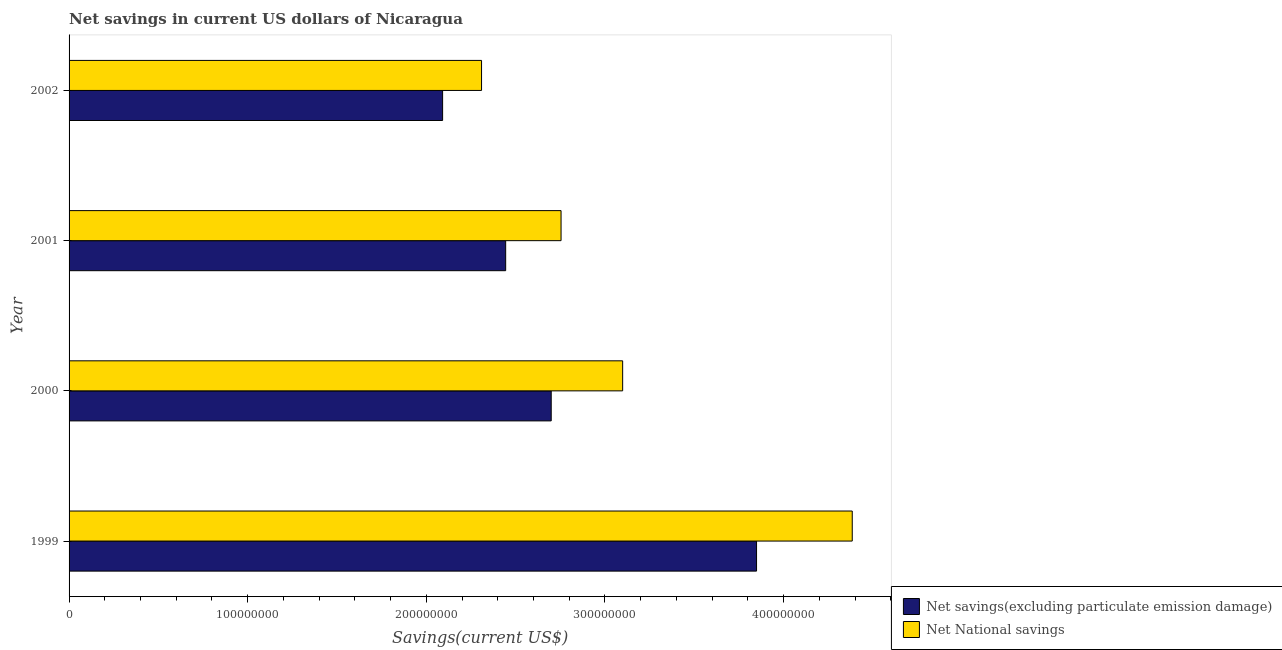How many groups of bars are there?
Offer a terse response. 4. Are the number of bars on each tick of the Y-axis equal?
Provide a short and direct response. Yes. How many bars are there on the 1st tick from the top?
Give a very brief answer. 2. In how many cases, is the number of bars for a given year not equal to the number of legend labels?
Ensure brevity in your answer.  0. What is the net savings(excluding particulate emission damage) in 2002?
Ensure brevity in your answer.  2.09e+08. Across all years, what is the maximum net savings(excluding particulate emission damage)?
Offer a terse response. 3.85e+08. Across all years, what is the minimum net national savings?
Your answer should be compact. 2.31e+08. In which year was the net savings(excluding particulate emission damage) minimum?
Ensure brevity in your answer.  2002. What is the total net national savings in the graph?
Keep it short and to the point. 1.25e+09. What is the difference between the net savings(excluding particulate emission damage) in 2000 and that in 2002?
Provide a succinct answer. 6.08e+07. What is the difference between the net savings(excluding particulate emission damage) in 2000 and the net national savings in 2001?
Ensure brevity in your answer.  -5.50e+06. What is the average net savings(excluding particulate emission damage) per year?
Make the answer very short. 2.77e+08. In the year 2002, what is the difference between the net national savings and net savings(excluding particulate emission damage)?
Provide a short and direct response. 2.18e+07. What is the ratio of the net national savings in 2000 to that in 2002?
Offer a very short reply. 1.34. Is the difference between the net savings(excluding particulate emission damage) in 2000 and 2002 greater than the difference between the net national savings in 2000 and 2002?
Offer a terse response. No. What is the difference between the highest and the second highest net savings(excluding particulate emission damage)?
Give a very brief answer. 1.15e+08. What is the difference between the highest and the lowest net savings(excluding particulate emission damage)?
Offer a very short reply. 1.76e+08. What does the 2nd bar from the top in 2002 represents?
Ensure brevity in your answer.  Net savings(excluding particulate emission damage). What does the 1st bar from the bottom in 2000 represents?
Your response must be concise. Net savings(excluding particulate emission damage). How many bars are there?
Your response must be concise. 8. How many years are there in the graph?
Ensure brevity in your answer.  4. What is the difference between two consecutive major ticks on the X-axis?
Give a very brief answer. 1.00e+08. Does the graph contain grids?
Make the answer very short. No. How many legend labels are there?
Your answer should be compact. 2. How are the legend labels stacked?
Provide a short and direct response. Vertical. What is the title of the graph?
Give a very brief answer. Net savings in current US dollars of Nicaragua. What is the label or title of the X-axis?
Give a very brief answer. Savings(current US$). What is the label or title of the Y-axis?
Your answer should be very brief. Year. What is the Savings(current US$) of Net savings(excluding particulate emission damage) in 1999?
Provide a short and direct response. 3.85e+08. What is the Savings(current US$) in Net National savings in 1999?
Offer a very short reply. 4.38e+08. What is the Savings(current US$) of Net savings(excluding particulate emission damage) in 2000?
Provide a succinct answer. 2.70e+08. What is the Savings(current US$) in Net National savings in 2000?
Keep it short and to the point. 3.10e+08. What is the Savings(current US$) of Net savings(excluding particulate emission damage) in 2001?
Ensure brevity in your answer.  2.44e+08. What is the Savings(current US$) of Net National savings in 2001?
Provide a succinct answer. 2.75e+08. What is the Savings(current US$) of Net savings(excluding particulate emission damage) in 2002?
Provide a short and direct response. 2.09e+08. What is the Savings(current US$) of Net National savings in 2002?
Keep it short and to the point. 2.31e+08. Across all years, what is the maximum Savings(current US$) in Net savings(excluding particulate emission damage)?
Provide a short and direct response. 3.85e+08. Across all years, what is the maximum Savings(current US$) of Net National savings?
Offer a terse response. 4.38e+08. Across all years, what is the minimum Savings(current US$) of Net savings(excluding particulate emission damage)?
Ensure brevity in your answer.  2.09e+08. Across all years, what is the minimum Savings(current US$) in Net National savings?
Offer a very short reply. 2.31e+08. What is the total Savings(current US$) of Net savings(excluding particulate emission damage) in the graph?
Offer a terse response. 1.11e+09. What is the total Savings(current US$) of Net National savings in the graph?
Provide a succinct answer. 1.25e+09. What is the difference between the Savings(current US$) in Net savings(excluding particulate emission damage) in 1999 and that in 2000?
Ensure brevity in your answer.  1.15e+08. What is the difference between the Savings(current US$) in Net National savings in 1999 and that in 2000?
Offer a very short reply. 1.29e+08. What is the difference between the Savings(current US$) of Net savings(excluding particulate emission damage) in 1999 and that in 2001?
Ensure brevity in your answer.  1.40e+08. What is the difference between the Savings(current US$) in Net National savings in 1999 and that in 2001?
Give a very brief answer. 1.63e+08. What is the difference between the Savings(current US$) of Net savings(excluding particulate emission damage) in 1999 and that in 2002?
Make the answer very short. 1.76e+08. What is the difference between the Savings(current US$) in Net National savings in 1999 and that in 2002?
Ensure brevity in your answer.  2.08e+08. What is the difference between the Savings(current US$) in Net savings(excluding particulate emission damage) in 2000 and that in 2001?
Make the answer very short. 2.55e+07. What is the difference between the Savings(current US$) of Net National savings in 2000 and that in 2001?
Offer a terse response. 3.45e+07. What is the difference between the Savings(current US$) of Net savings(excluding particulate emission damage) in 2000 and that in 2002?
Make the answer very short. 6.08e+07. What is the difference between the Savings(current US$) of Net National savings in 2000 and that in 2002?
Offer a terse response. 7.90e+07. What is the difference between the Savings(current US$) of Net savings(excluding particulate emission damage) in 2001 and that in 2002?
Make the answer very short. 3.53e+07. What is the difference between the Savings(current US$) of Net National savings in 2001 and that in 2002?
Your response must be concise. 4.45e+07. What is the difference between the Savings(current US$) in Net savings(excluding particulate emission damage) in 1999 and the Savings(current US$) in Net National savings in 2000?
Keep it short and to the point. 7.50e+07. What is the difference between the Savings(current US$) in Net savings(excluding particulate emission damage) in 1999 and the Savings(current US$) in Net National savings in 2001?
Provide a succinct answer. 1.09e+08. What is the difference between the Savings(current US$) of Net savings(excluding particulate emission damage) in 1999 and the Savings(current US$) of Net National savings in 2002?
Your answer should be compact. 1.54e+08. What is the difference between the Savings(current US$) of Net savings(excluding particulate emission damage) in 2000 and the Savings(current US$) of Net National savings in 2001?
Give a very brief answer. -5.50e+06. What is the difference between the Savings(current US$) in Net savings(excluding particulate emission damage) in 2000 and the Savings(current US$) in Net National savings in 2002?
Your response must be concise. 3.90e+07. What is the difference between the Savings(current US$) in Net savings(excluding particulate emission damage) in 2001 and the Savings(current US$) in Net National savings in 2002?
Ensure brevity in your answer.  1.35e+07. What is the average Savings(current US$) in Net savings(excluding particulate emission damage) per year?
Give a very brief answer. 2.77e+08. What is the average Savings(current US$) in Net National savings per year?
Make the answer very short. 3.14e+08. In the year 1999, what is the difference between the Savings(current US$) of Net savings(excluding particulate emission damage) and Savings(current US$) of Net National savings?
Ensure brevity in your answer.  -5.36e+07. In the year 2000, what is the difference between the Savings(current US$) in Net savings(excluding particulate emission damage) and Savings(current US$) in Net National savings?
Your answer should be very brief. -4.00e+07. In the year 2001, what is the difference between the Savings(current US$) of Net savings(excluding particulate emission damage) and Savings(current US$) of Net National savings?
Keep it short and to the point. -3.10e+07. In the year 2002, what is the difference between the Savings(current US$) in Net savings(excluding particulate emission damage) and Savings(current US$) in Net National savings?
Your answer should be compact. -2.18e+07. What is the ratio of the Savings(current US$) in Net savings(excluding particulate emission damage) in 1999 to that in 2000?
Offer a terse response. 1.43. What is the ratio of the Savings(current US$) in Net National savings in 1999 to that in 2000?
Offer a terse response. 1.41. What is the ratio of the Savings(current US$) in Net savings(excluding particulate emission damage) in 1999 to that in 2001?
Make the answer very short. 1.57. What is the ratio of the Savings(current US$) of Net National savings in 1999 to that in 2001?
Your answer should be compact. 1.59. What is the ratio of the Savings(current US$) in Net savings(excluding particulate emission damage) in 1999 to that in 2002?
Offer a very short reply. 1.84. What is the ratio of the Savings(current US$) in Net National savings in 1999 to that in 2002?
Offer a terse response. 1.9. What is the ratio of the Savings(current US$) of Net savings(excluding particulate emission damage) in 2000 to that in 2001?
Make the answer very short. 1.1. What is the ratio of the Savings(current US$) of Net National savings in 2000 to that in 2001?
Provide a succinct answer. 1.13. What is the ratio of the Savings(current US$) of Net savings(excluding particulate emission damage) in 2000 to that in 2002?
Your answer should be very brief. 1.29. What is the ratio of the Savings(current US$) in Net National savings in 2000 to that in 2002?
Ensure brevity in your answer.  1.34. What is the ratio of the Savings(current US$) of Net savings(excluding particulate emission damage) in 2001 to that in 2002?
Your answer should be very brief. 1.17. What is the ratio of the Savings(current US$) of Net National savings in 2001 to that in 2002?
Provide a succinct answer. 1.19. What is the difference between the highest and the second highest Savings(current US$) of Net savings(excluding particulate emission damage)?
Give a very brief answer. 1.15e+08. What is the difference between the highest and the second highest Savings(current US$) in Net National savings?
Keep it short and to the point. 1.29e+08. What is the difference between the highest and the lowest Savings(current US$) of Net savings(excluding particulate emission damage)?
Ensure brevity in your answer.  1.76e+08. What is the difference between the highest and the lowest Savings(current US$) of Net National savings?
Offer a terse response. 2.08e+08. 